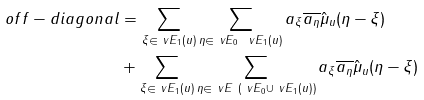Convert formula to latex. <formula><loc_0><loc_0><loc_500><loc_500>o f f - d i a g o n a l & = \sum _ { \xi \in \ v E _ { 1 } ( u ) } \sum _ { \eta \in \ v E _ { 0 } \ \ v E _ { 1 } ( u ) } a _ { \xi } \overline { a _ { \eta } } \hat { \mu } _ { u } ( \eta - \xi ) \\ & + \sum _ { \xi \in \ v E _ { 1 } ( u ) } \sum _ { \eta \in \ v E \ ( \ v E _ { 0 } \cup \ v E _ { 1 } ( u ) ) } a _ { \xi } \overline { a _ { \eta } } \hat { \mu } _ { u } ( \eta - \xi )</formula> 